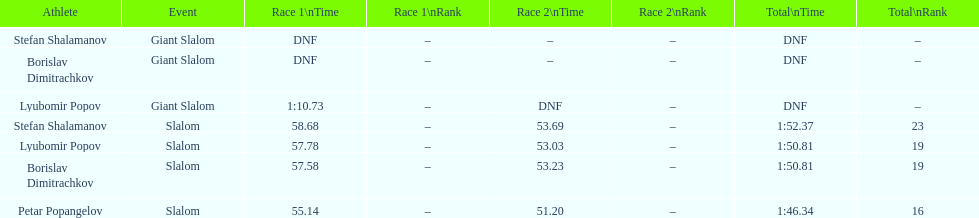How many athletes are there total? 4. 